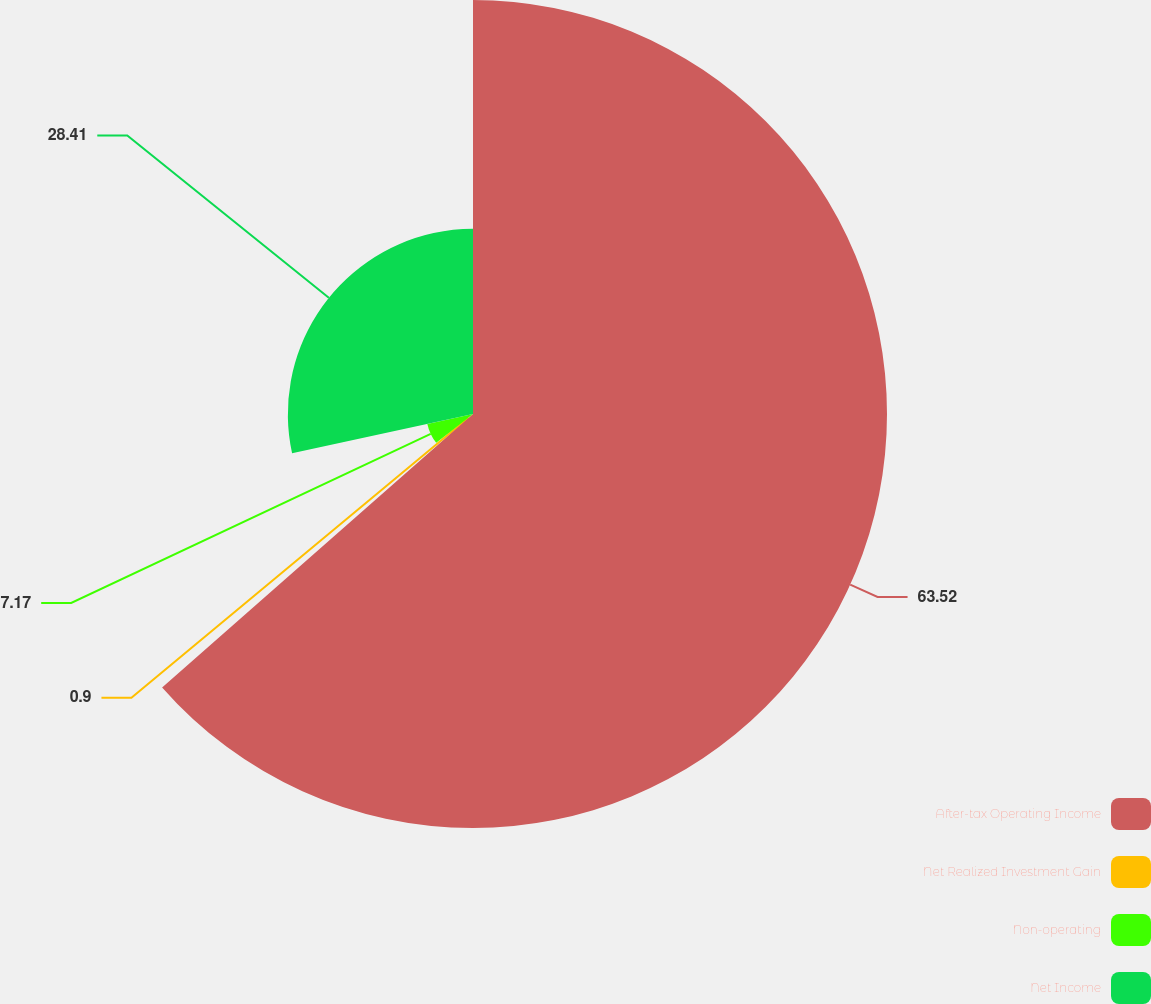Convert chart to OTSL. <chart><loc_0><loc_0><loc_500><loc_500><pie_chart><fcel>After-tax Operating Income<fcel>Net Realized Investment Gain<fcel>Non-operating<fcel>Net Income<nl><fcel>63.52%<fcel>0.9%<fcel>7.17%<fcel>28.41%<nl></chart> 